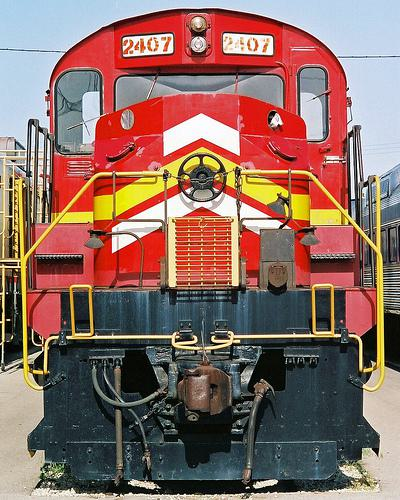What model is this train, and can you tell me more about its design? This appears to be a diesel locomotive, possibly from the mid to late 20th century. Its design suggests that it's built for freight duties, given its robust frame and the large radiator grille at the front, which is crucial for cooling the diesel engine during heavy haulage. 